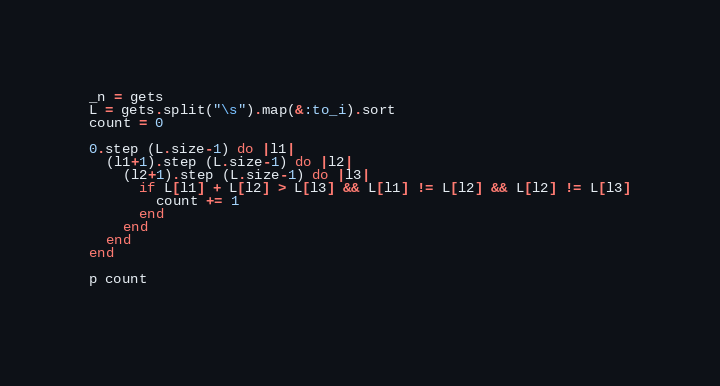<code> <loc_0><loc_0><loc_500><loc_500><_Ruby_>_n = gets
L = gets.split("\s").map(&:to_i).sort
count = 0

0.step (L.size-1) do |l1|
  (l1+1).step (L.size-1) do |l2|
    (l2+1).step (L.size-1) do |l3|
      if L[l1] + L[l2] > L[l3] && L[l1] != L[l2] && L[l2] != L[l3]
        count += 1
      end
    end
  end
end

p count
        </code> 